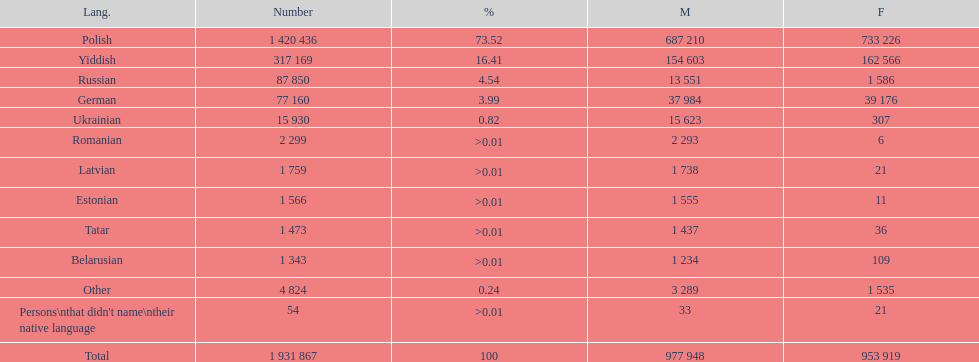Is german above or below russia in the number of people who speak that language? Below. 